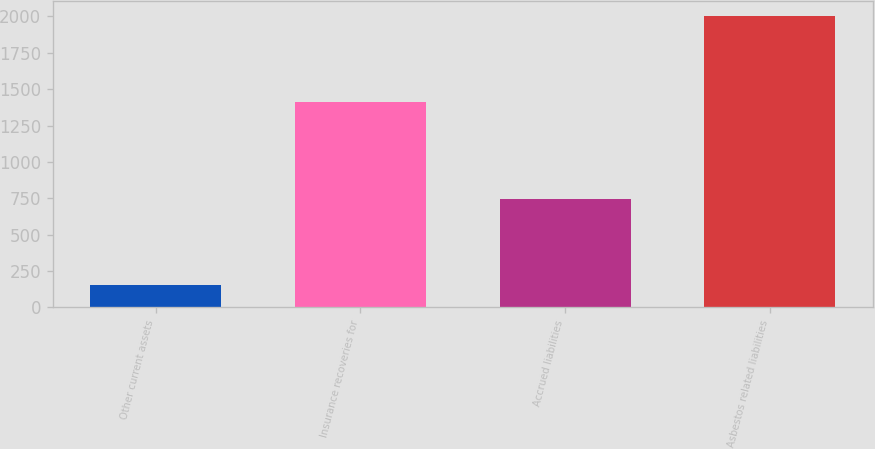Convert chart to OTSL. <chart><loc_0><loc_0><loc_500><loc_500><bar_chart><fcel>Other current assets<fcel>Insurance recoveries for<fcel>Accrued liabilities<fcel>Asbestos related liabilities<nl><fcel>150<fcel>1412<fcel>744<fcel>2006<nl></chart> 